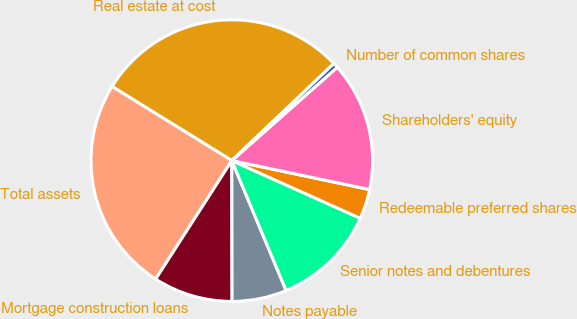Convert chart. <chart><loc_0><loc_0><loc_500><loc_500><pie_chart><fcel>Real estate at cost<fcel>Total assets<fcel>Mortgage construction loans<fcel>Notes payable<fcel>Senior notes and debentures<fcel>Redeemable preferred shares<fcel>Shareholders' equity<fcel>Number of common shares<nl><fcel>29.08%<fcel>24.73%<fcel>9.12%<fcel>6.27%<fcel>11.98%<fcel>3.42%<fcel>14.83%<fcel>0.57%<nl></chart> 